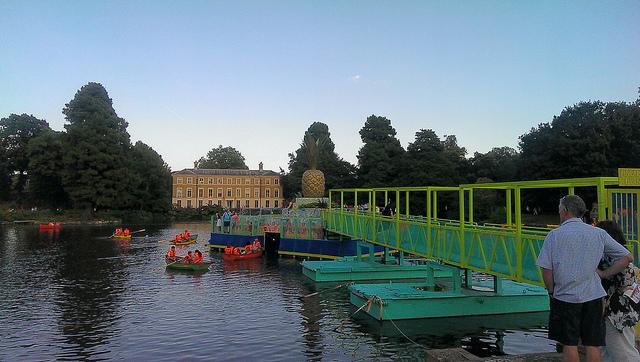How many boats are there?
Be succinct. 5. What are the people doing in the distance?
Short answer required. Rowing. What color is the water?
Give a very brief answer. Blue. What city is this?
Short answer required. London. What are the couple looking at?
Answer briefly. Boats. How many people are in this image?
Short answer required. 20. How many people are in the picture?
Quick response, please. 15. 